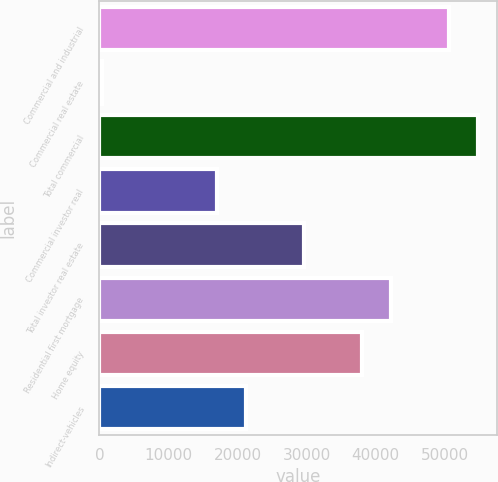Convert chart. <chart><loc_0><loc_0><loc_500><loc_500><bar_chart><fcel>Commercial and industrial<fcel>Commercial real estate<fcel>Total commercial<fcel>Commercial investor real<fcel>Total investor real estate<fcel>Residential first mortgage<fcel>Home equity<fcel>Indirect-vehicles<nl><fcel>50588.8<fcel>334<fcel>54776.7<fcel>17085.6<fcel>29649.3<fcel>42213<fcel>38025.1<fcel>21273.5<nl></chart> 